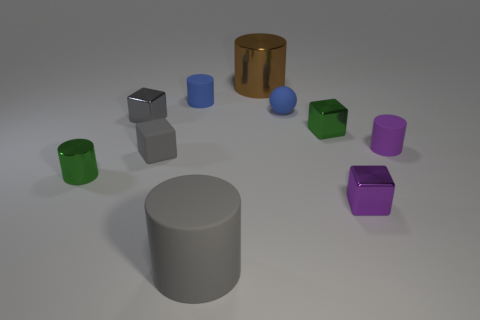Are there any patterns or order in the way these objects are arranged? There doesn't seem to be a specific pattern to the arrangement of these objects. They are scattered across the surface without a discernible order. 